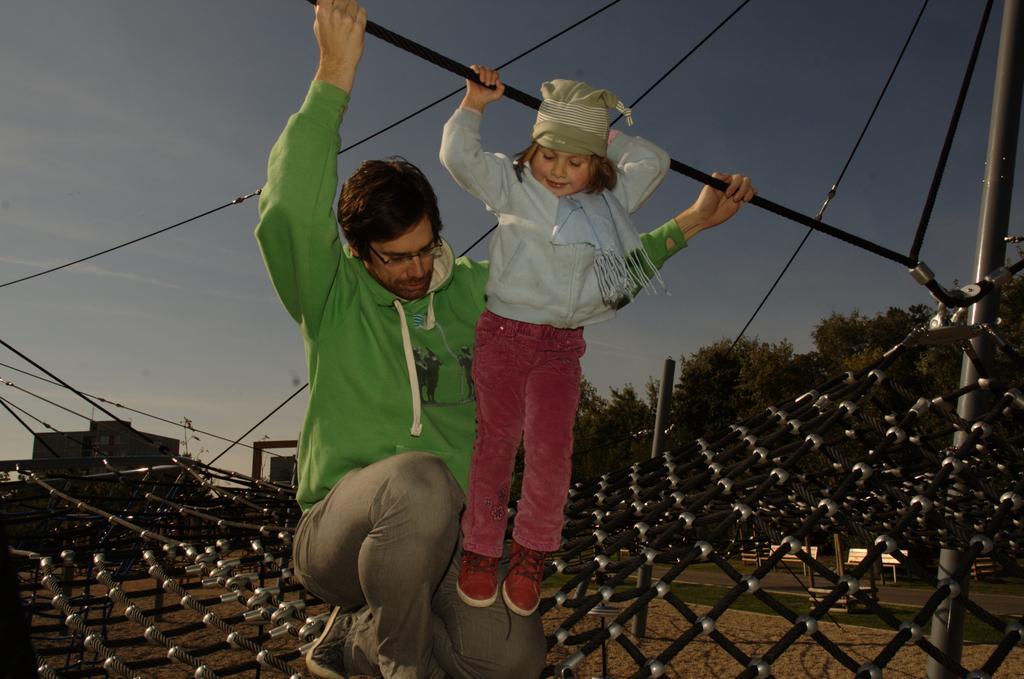In one or two sentences, can you explain what this image depicts? Here we can see a man and kid are holding a rope. At the bottom, we can see a net, ground. Background we can see few poles, trees, wires, ropes, benches and sky. 